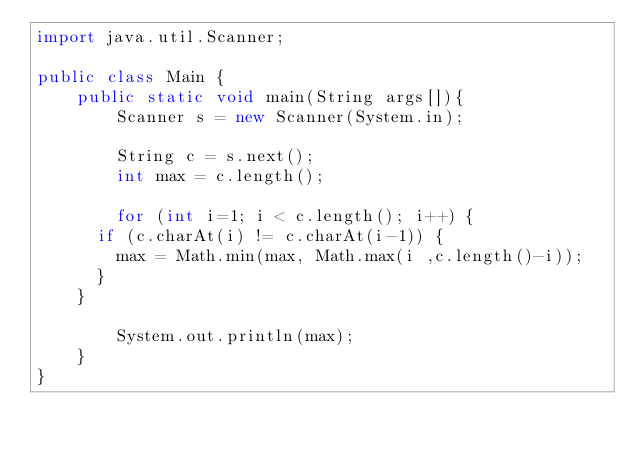Convert code to text. <code><loc_0><loc_0><loc_500><loc_500><_Java_>import java.util.Scanner;

public class Main {
	public static void main(String args[]){
		Scanner s = new Scanner(System.in);

		String c = s.next();
		int max = c.length();

		for (int i=1; i < c.length(); i++) {
      if (c.charAt(i) != c.charAt(i-1)) {
        max = Math.min(max, Math.max(i ,c.length()-i));
      }
    }

		System.out.println(max);
	}
}
</code> 